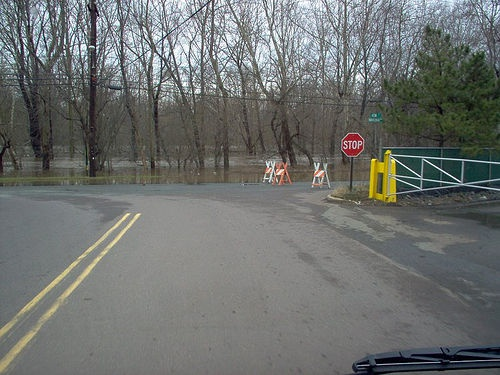Describe the objects in this image and their specific colors. I can see a stop sign in gray, brown, maroon, and darkgray tones in this image. 